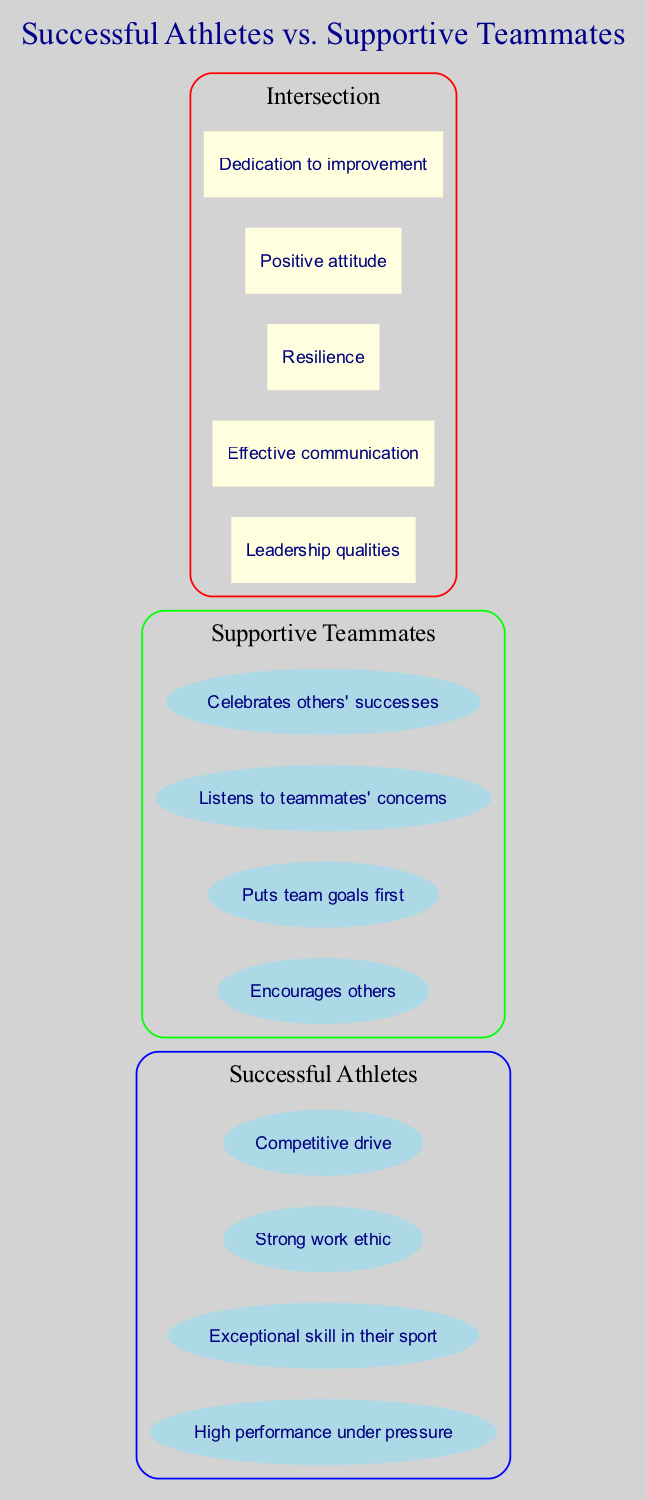What are two attributes of successful athletes? Looking at the set labeled "Successful Athletes," I can identify at least two attributes listed: "High performance under pressure" and "Exceptional skill in their sport".
Answer: High performance under pressure, Exceptional skill in their sport How many attributes are listed under supportive teammates? The set labeled "Supportive Teammates" contains four attributes: "Encourages others," "Puts team goals first," "Listens to teammates' concerns," and "Celebrates others' successes," giving a total of four attributes.
Answer: 4 What is one shared attribute between successful athletes and supportive teammates? In the intersection of both sets, the shared attributes include "Leadership qualities," "Effective communication," "Resilience," "Positive attitude," and "Dedication to improvement." Thus, one of the shared attributes could be "Leadership qualities."
Answer: Leadership qualities Which attribute is unique to supportive teammates? Referring to the set labeled "Supportive Teammates," I notice that "Encourages others" is not found in the attributes of successful athletes, indicating it is unique.
Answer: Encourages others How many total attributes are present in the diagram? Combining the attributes in both set labels and the intersection, Successful Athletes has four attributes, Supportive Teammates has four, and the intersection has five. Adding these together yields 4 + 4 + 5 = 13 total attributes.
Answer: 13 What is the color associated with supportive teammates in the diagram? Upon examining the set labeled "Supportive Teammates," it is noted that the color used is green, which visually distinguishes it from other sets.
Answer: Green Which attribute in the intersection describes a valuable mindset? The attribute "Positive attitude" can be found in the intersection of both sets, highlighting a valuable mindset that is important for both successful athletes and supportive teammates.
Answer: Positive attitude Name an attribute that indicates competitiveness. In the set labeled "Successful Athletes," the attribute "Competitive drive" clearly indicates a mindset associated with competitiveness, distinguishing these athletes.
Answer: Competitive drive Which attribute emphasizes a commitment to progress? The attribute "Dedication to improvement" appears in the intersection of both sets, highlighting a commitment to personal and team growth, relevant to both groups.
Answer: Dedication to improvement 